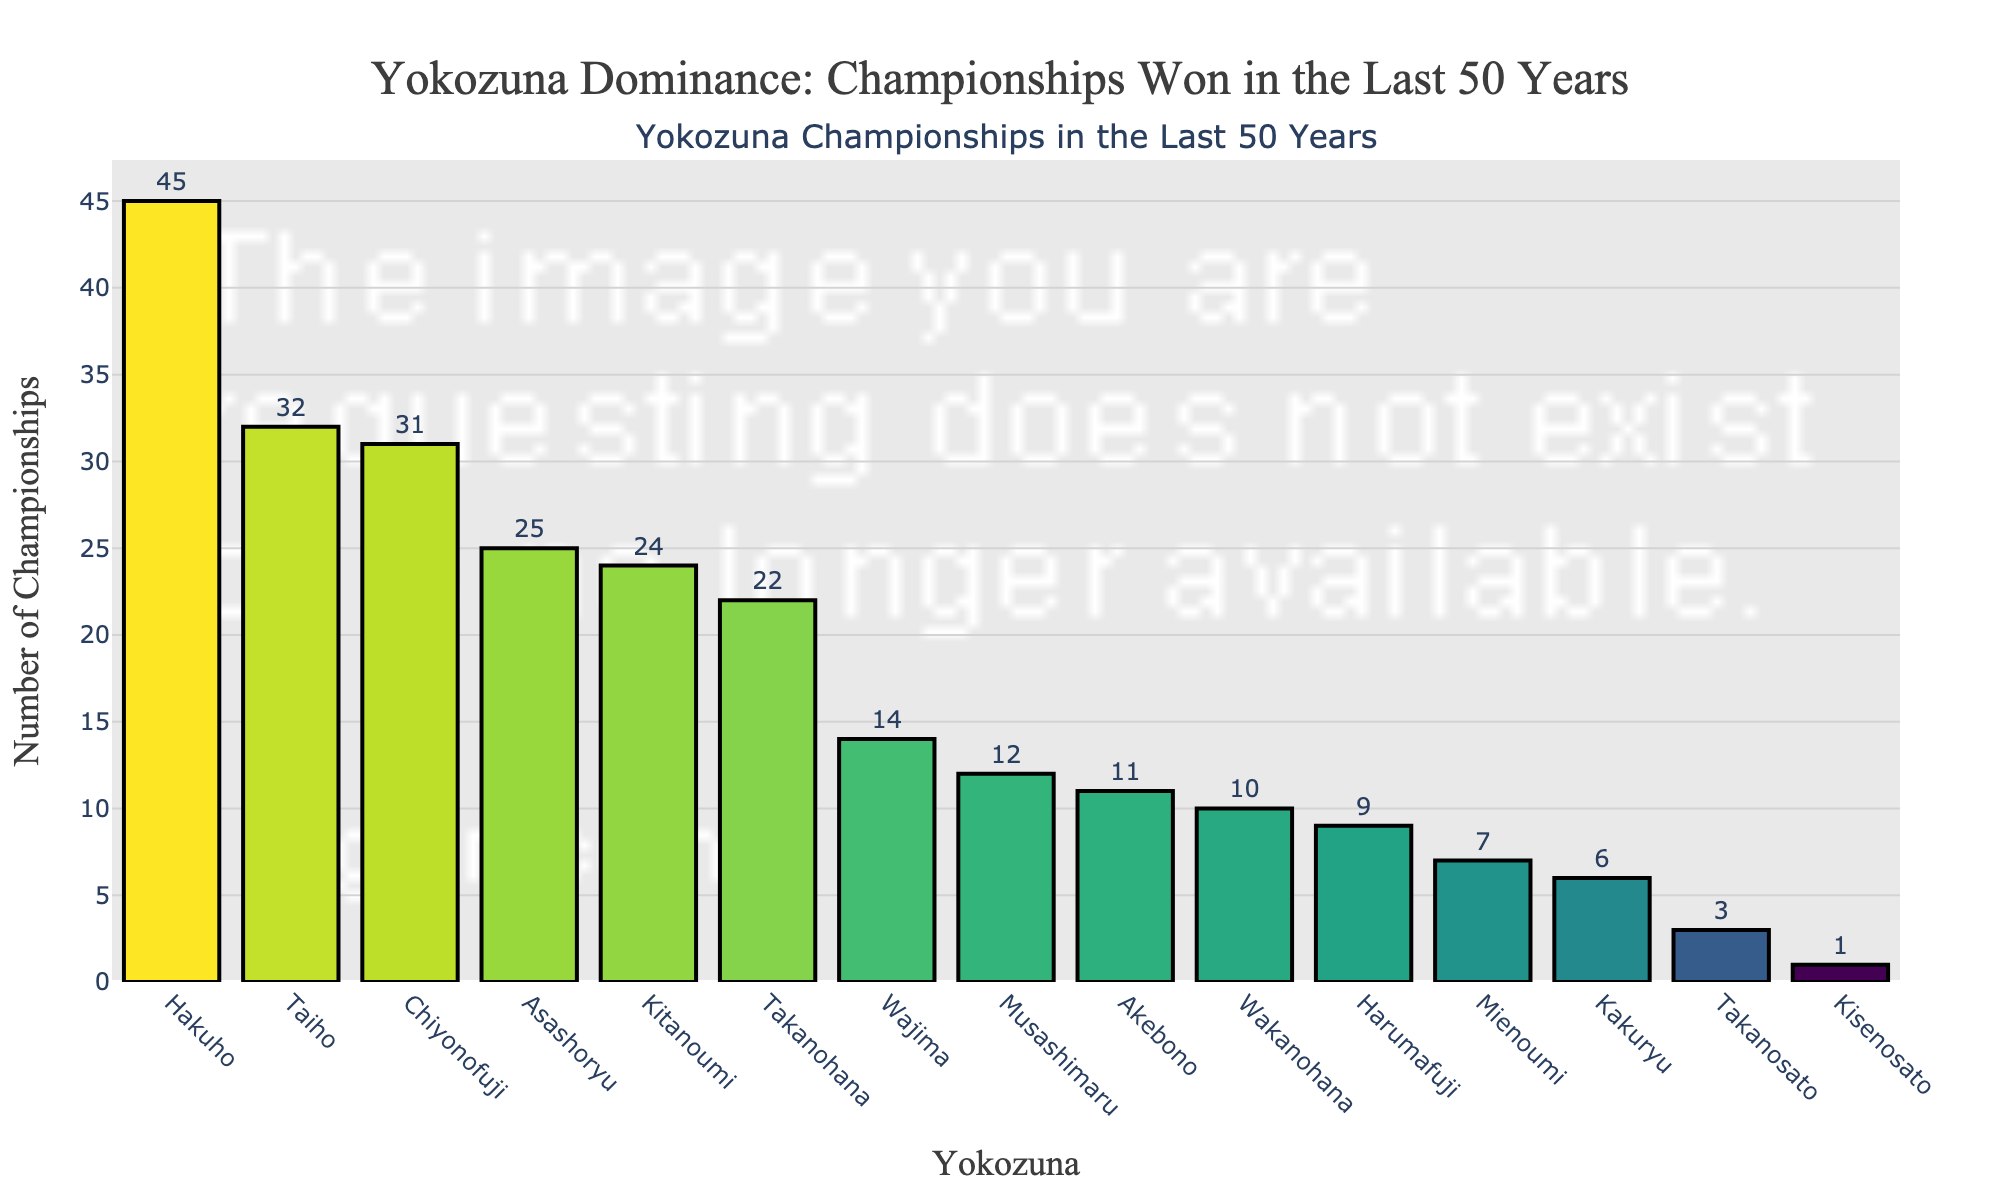what's the median number of championships won by Yokozuna? To find the median, sort the number of championships in ascending order and find the middle value. The sorted numbers are 1, 3, 6, 7, 9, 10, 11, 12, 14, 22, 24, 25, 31, 32, 45. The middle value (8th element) is 12
Answer: 12 Which Yokozuna has won the fewest number of championships? Inspect the bars to identify the shortest one. The shortest bar corresponds to Kisenosato with 1 championship
Answer: Kisenosato How many more championships has Hakuho won compared to Chiyonofuji? Hakuho won 45 championships and Chiyonofuji won 31. The difference is 45 - 31 = 14
Answer: 14 Which Yokozuna have won more than 30 championships? Identify bars with values over 30. Hakuho, Taiho, and Chiyonofuji have more than 30 championships
Answer: Hakuho, Taiho, Chiyonofuji Is it true that Asashoryu won more championships than Kitanoumi? Compare the heights of the bars for Asashoryu and Kitanoumi. Asashoryu won 25 championships while Kitanoumi won 24
Answer: True How many more championships have Hakuho and Taiho won combined compared to Asashoryu and Kitanoumi combined? Hakuho and Taiho won 45 + 32 = 77 championships. Asashoryu and Kitanoumi won 25 + 24 = 49 championships. The difference is 77 - 49 = 28
Answer: 28 Which two Yokozuna have won 10 or fewer championships? Find bars with heights corresponding to 10 or fewer. Wakanohana (10) and Kisenosato (1) have 10 or fewer
Answer: Wakanohana, Kisenosato Who won more championships, Musashimaru or Akebono? Compare the bar heights for Musashimaru and Akebono. Musashimaru won 12 championships, Akebono won 11
Answer: Musashimaru What's the average number of championships won by the listed Yokozuna? Sum the number of championships and divide by the count of Yokozuna. The sum is 252, divided by 15 Yokozuna gives an average of 252/15 = 16.8
Answer: 16.8 